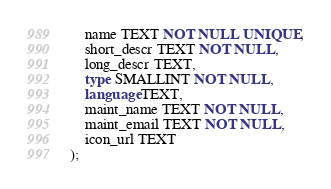<code> <loc_0><loc_0><loc_500><loc_500><_SQL_>	name TEXT NOT NULL UNIQUE,
	short_descr TEXT NOT NULL,
	long_descr TEXT,
	type SMALLINT NOT NULL,
	language TEXT,
	maint_name TEXT NOT NULL,
	maint_email TEXT NOT NULL,
	icon_url TEXT
);</code> 